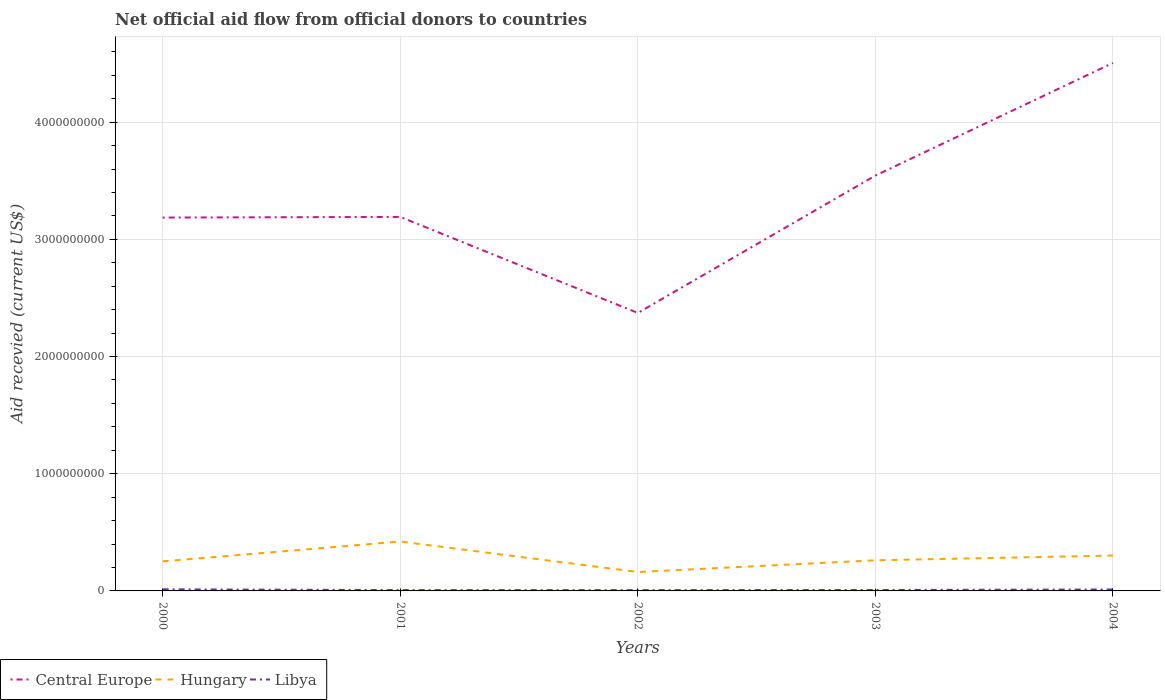Across all years, what is the maximum total aid received in Hungary?
Keep it short and to the point. 1.62e+08. In which year was the total aid received in Central Europe maximum?
Your response must be concise. 2002. What is the total total aid received in Central Europe in the graph?
Provide a succinct answer. 8.19e+08. What is the difference between the highest and the second highest total aid received in Central Europe?
Give a very brief answer. 2.13e+09. Is the total aid received in Hungary strictly greater than the total aid received in Libya over the years?
Ensure brevity in your answer.  No. What is the difference between two consecutive major ticks on the Y-axis?
Keep it short and to the point. 1.00e+09. Are the values on the major ticks of Y-axis written in scientific E-notation?
Keep it short and to the point. No. Does the graph contain grids?
Offer a very short reply. Yes. Where does the legend appear in the graph?
Your answer should be very brief. Bottom left. How many legend labels are there?
Your answer should be very brief. 3. What is the title of the graph?
Offer a very short reply. Net official aid flow from official donors to countries. What is the label or title of the Y-axis?
Keep it short and to the point. Aid recevied (current US$). What is the Aid recevied (current US$) in Central Europe in 2000?
Keep it short and to the point. 3.19e+09. What is the Aid recevied (current US$) in Hungary in 2000?
Ensure brevity in your answer.  2.52e+08. What is the Aid recevied (current US$) in Libya in 2000?
Provide a succinct answer. 1.38e+07. What is the Aid recevied (current US$) in Central Europe in 2001?
Ensure brevity in your answer.  3.19e+09. What is the Aid recevied (current US$) of Hungary in 2001?
Keep it short and to the point. 4.22e+08. What is the Aid recevied (current US$) in Libya in 2001?
Your answer should be very brief. 7.14e+06. What is the Aid recevied (current US$) of Central Europe in 2002?
Give a very brief answer. 2.37e+09. What is the Aid recevied (current US$) in Hungary in 2002?
Your answer should be very brief. 1.62e+08. What is the Aid recevied (current US$) of Libya in 2002?
Your answer should be very brief. 6.88e+06. What is the Aid recevied (current US$) of Central Europe in 2003?
Your response must be concise. 3.54e+09. What is the Aid recevied (current US$) of Hungary in 2003?
Keep it short and to the point. 2.61e+08. What is the Aid recevied (current US$) in Libya in 2003?
Make the answer very short. 7.95e+06. What is the Aid recevied (current US$) in Central Europe in 2004?
Give a very brief answer. 4.51e+09. What is the Aid recevied (current US$) of Hungary in 2004?
Your response must be concise. 3.02e+08. What is the Aid recevied (current US$) in Libya in 2004?
Offer a terse response. 1.24e+07. Across all years, what is the maximum Aid recevied (current US$) in Central Europe?
Ensure brevity in your answer.  4.51e+09. Across all years, what is the maximum Aid recevied (current US$) of Hungary?
Your answer should be compact. 4.22e+08. Across all years, what is the maximum Aid recevied (current US$) in Libya?
Offer a very short reply. 1.38e+07. Across all years, what is the minimum Aid recevied (current US$) in Central Europe?
Ensure brevity in your answer.  2.37e+09. Across all years, what is the minimum Aid recevied (current US$) of Hungary?
Offer a very short reply. 1.62e+08. Across all years, what is the minimum Aid recevied (current US$) in Libya?
Offer a very short reply. 6.88e+06. What is the total Aid recevied (current US$) in Central Europe in the graph?
Make the answer very short. 1.68e+1. What is the total Aid recevied (current US$) of Hungary in the graph?
Your response must be concise. 1.40e+09. What is the total Aid recevied (current US$) in Libya in the graph?
Your answer should be very brief. 4.82e+07. What is the difference between the Aid recevied (current US$) in Central Europe in 2000 and that in 2001?
Your answer should be compact. -5.47e+06. What is the difference between the Aid recevied (current US$) of Hungary in 2000 and that in 2001?
Offer a very short reply. -1.70e+08. What is the difference between the Aid recevied (current US$) of Libya in 2000 and that in 2001?
Offer a very short reply. 6.61e+06. What is the difference between the Aid recevied (current US$) in Central Europe in 2000 and that in 2002?
Provide a short and direct response. 8.14e+08. What is the difference between the Aid recevied (current US$) of Hungary in 2000 and that in 2002?
Offer a very short reply. 9.06e+07. What is the difference between the Aid recevied (current US$) of Libya in 2000 and that in 2002?
Offer a terse response. 6.87e+06. What is the difference between the Aid recevied (current US$) in Central Europe in 2000 and that in 2003?
Provide a short and direct response. -3.59e+08. What is the difference between the Aid recevied (current US$) of Hungary in 2000 and that in 2003?
Offer a very short reply. -9.28e+06. What is the difference between the Aid recevied (current US$) of Libya in 2000 and that in 2003?
Provide a short and direct response. 5.80e+06. What is the difference between the Aid recevied (current US$) of Central Europe in 2000 and that in 2004?
Your answer should be very brief. -1.32e+09. What is the difference between the Aid recevied (current US$) in Hungary in 2000 and that in 2004?
Make the answer very short. -4.98e+07. What is the difference between the Aid recevied (current US$) in Libya in 2000 and that in 2004?
Make the answer very short. 1.32e+06. What is the difference between the Aid recevied (current US$) in Central Europe in 2001 and that in 2002?
Provide a succinct answer. 8.19e+08. What is the difference between the Aid recevied (current US$) in Hungary in 2001 and that in 2002?
Your response must be concise. 2.60e+08. What is the difference between the Aid recevied (current US$) in Central Europe in 2001 and that in 2003?
Your answer should be compact. -3.53e+08. What is the difference between the Aid recevied (current US$) in Hungary in 2001 and that in 2003?
Ensure brevity in your answer.  1.60e+08. What is the difference between the Aid recevied (current US$) of Libya in 2001 and that in 2003?
Offer a terse response. -8.10e+05. What is the difference between the Aid recevied (current US$) in Central Europe in 2001 and that in 2004?
Offer a very short reply. -1.31e+09. What is the difference between the Aid recevied (current US$) in Hungary in 2001 and that in 2004?
Make the answer very short. 1.20e+08. What is the difference between the Aid recevied (current US$) of Libya in 2001 and that in 2004?
Make the answer very short. -5.29e+06. What is the difference between the Aid recevied (current US$) of Central Europe in 2002 and that in 2003?
Keep it short and to the point. -1.17e+09. What is the difference between the Aid recevied (current US$) in Hungary in 2002 and that in 2003?
Your answer should be very brief. -9.99e+07. What is the difference between the Aid recevied (current US$) of Libya in 2002 and that in 2003?
Offer a terse response. -1.07e+06. What is the difference between the Aid recevied (current US$) in Central Europe in 2002 and that in 2004?
Provide a short and direct response. -2.13e+09. What is the difference between the Aid recevied (current US$) of Hungary in 2002 and that in 2004?
Give a very brief answer. -1.40e+08. What is the difference between the Aid recevied (current US$) in Libya in 2002 and that in 2004?
Provide a short and direct response. -5.55e+06. What is the difference between the Aid recevied (current US$) in Central Europe in 2003 and that in 2004?
Ensure brevity in your answer.  -9.61e+08. What is the difference between the Aid recevied (current US$) in Hungary in 2003 and that in 2004?
Provide a succinct answer. -4.06e+07. What is the difference between the Aid recevied (current US$) of Libya in 2003 and that in 2004?
Provide a succinct answer. -4.48e+06. What is the difference between the Aid recevied (current US$) in Central Europe in 2000 and the Aid recevied (current US$) in Hungary in 2001?
Give a very brief answer. 2.76e+09. What is the difference between the Aid recevied (current US$) in Central Europe in 2000 and the Aid recevied (current US$) in Libya in 2001?
Ensure brevity in your answer.  3.18e+09. What is the difference between the Aid recevied (current US$) in Hungary in 2000 and the Aid recevied (current US$) in Libya in 2001?
Ensure brevity in your answer.  2.45e+08. What is the difference between the Aid recevied (current US$) in Central Europe in 2000 and the Aid recevied (current US$) in Hungary in 2002?
Keep it short and to the point. 3.02e+09. What is the difference between the Aid recevied (current US$) in Central Europe in 2000 and the Aid recevied (current US$) in Libya in 2002?
Make the answer very short. 3.18e+09. What is the difference between the Aid recevied (current US$) of Hungary in 2000 and the Aid recevied (current US$) of Libya in 2002?
Provide a succinct answer. 2.45e+08. What is the difference between the Aid recevied (current US$) in Central Europe in 2000 and the Aid recevied (current US$) in Hungary in 2003?
Provide a short and direct response. 2.92e+09. What is the difference between the Aid recevied (current US$) of Central Europe in 2000 and the Aid recevied (current US$) of Libya in 2003?
Ensure brevity in your answer.  3.18e+09. What is the difference between the Aid recevied (current US$) of Hungary in 2000 and the Aid recevied (current US$) of Libya in 2003?
Your answer should be very brief. 2.44e+08. What is the difference between the Aid recevied (current US$) of Central Europe in 2000 and the Aid recevied (current US$) of Hungary in 2004?
Provide a succinct answer. 2.88e+09. What is the difference between the Aid recevied (current US$) in Central Europe in 2000 and the Aid recevied (current US$) in Libya in 2004?
Provide a succinct answer. 3.17e+09. What is the difference between the Aid recevied (current US$) in Hungary in 2000 and the Aid recevied (current US$) in Libya in 2004?
Offer a very short reply. 2.40e+08. What is the difference between the Aid recevied (current US$) of Central Europe in 2001 and the Aid recevied (current US$) of Hungary in 2002?
Your answer should be compact. 3.03e+09. What is the difference between the Aid recevied (current US$) in Central Europe in 2001 and the Aid recevied (current US$) in Libya in 2002?
Offer a very short reply. 3.18e+09. What is the difference between the Aid recevied (current US$) in Hungary in 2001 and the Aid recevied (current US$) in Libya in 2002?
Your answer should be very brief. 4.15e+08. What is the difference between the Aid recevied (current US$) of Central Europe in 2001 and the Aid recevied (current US$) of Hungary in 2003?
Your answer should be very brief. 2.93e+09. What is the difference between the Aid recevied (current US$) of Central Europe in 2001 and the Aid recevied (current US$) of Libya in 2003?
Give a very brief answer. 3.18e+09. What is the difference between the Aid recevied (current US$) of Hungary in 2001 and the Aid recevied (current US$) of Libya in 2003?
Provide a short and direct response. 4.14e+08. What is the difference between the Aid recevied (current US$) in Central Europe in 2001 and the Aid recevied (current US$) in Hungary in 2004?
Provide a succinct answer. 2.89e+09. What is the difference between the Aid recevied (current US$) in Central Europe in 2001 and the Aid recevied (current US$) in Libya in 2004?
Your answer should be very brief. 3.18e+09. What is the difference between the Aid recevied (current US$) in Hungary in 2001 and the Aid recevied (current US$) in Libya in 2004?
Provide a succinct answer. 4.09e+08. What is the difference between the Aid recevied (current US$) of Central Europe in 2002 and the Aid recevied (current US$) of Hungary in 2003?
Your answer should be very brief. 2.11e+09. What is the difference between the Aid recevied (current US$) in Central Europe in 2002 and the Aid recevied (current US$) in Libya in 2003?
Keep it short and to the point. 2.36e+09. What is the difference between the Aid recevied (current US$) in Hungary in 2002 and the Aid recevied (current US$) in Libya in 2003?
Your answer should be compact. 1.54e+08. What is the difference between the Aid recevied (current US$) in Central Europe in 2002 and the Aid recevied (current US$) in Hungary in 2004?
Ensure brevity in your answer.  2.07e+09. What is the difference between the Aid recevied (current US$) in Central Europe in 2002 and the Aid recevied (current US$) in Libya in 2004?
Ensure brevity in your answer.  2.36e+09. What is the difference between the Aid recevied (current US$) of Hungary in 2002 and the Aid recevied (current US$) of Libya in 2004?
Your answer should be compact. 1.49e+08. What is the difference between the Aid recevied (current US$) in Central Europe in 2003 and the Aid recevied (current US$) in Hungary in 2004?
Offer a very short reply. 3.24e+09. What is the difference between the Aid recevied (current US$) in Central Europe in 2003 and the Aid recevied (current US$) in Libya in 2004?
Your response must be concise. 3.53e+09. What is the difference between the Aid recevied (current US$) of Hungary in 2003 and the Aid recevied (current US$) of Libya in 2004?
Make the answer very short. 2.49e+08. What is the average Aid recevied (current US$) in Central Europe per year?
Ensure brevity in your answer.  3.36e+09. What is the average Aid recevied (current US$) in Hungary per year?
Your answer should be compact. 2.80e+08. What is the average Aid recevied (current US$) in Libya per year?
Your answer should be very brief. 9.63e+06. In the year 2000, what is the difference between the Aid recevied (current US$) of Central Europe and Aid recevied (current US$) of Hungary?
Ensure brevity in your answer.  2.93e+09. In the year 2000, what is the difference between the Aid recevied (current US$) of Central Europe and Aid recevied (current US$) of Libya?
Ensure brevity in your answer.  3.17e+09. In the year 2000, what is the difference between the Aid recevied (current US$) of Hungary and Aid recevied (current US$) of Libya?
Provide a succinct answer. 2.38e+08. In the year 2001, what is the difference between the Aid recevied (current US$) in Central Europe and Aid recevied (current US$) in Hungary?
Provide a short and direct response. 2.77e+09. In the year 2001, what is the difference between the Aid recevied (current US$) in Central Europe and Aid recevied (current US$) in Libya?
Offer a terse response. 3.18e+09. In the year 2001, what is the difference between the Aid recevied (current US$) of Hungary and Aid recevied (current US$) of Libya?
Keep it short and to the point. 4.15e+08. In the year 2002, what is the difference between the Aid recevied (current US$) of Central Europe and Aid recevied (current US$) of Hungary?
Offer a very short reply. 2.21e+09. In the year 2002, what is the difference between the Aid recevied (current US$) in Central Europe and Aid recevied (current US$) in Libya?
Provide a succinct answer. 2.37e+09. In the year 2002, what is the difference between the Aid recevied (current US$) of Hungary and Aid recevied (current US$) of Libya?
Ensure brevity in your answer.  1.55e+08. In the year 2003, what is the difference between the Aid recevied (current US$) of Central Europe and Aid recevied (current US$) of Hungary?
Provide a succinct answer. 3.28e+09. In the year 2003, what is the difference between the Aid recevied (current US$) of Central Europe and Aid recevied (current US$) of Libya?
Make the answer very short. 3.54e+09. In the year 2003, what is the difference between the Aid recevied (current US$) of Hungary and Aid recevied (current US$) of Libya?
Provide a succinct answer. 2.54e+08. In the year 2004, what is the difference between the Aid recevied (current US$) in Central Europe and Aid recevied (current US$) in Hungary?
Provide a succinct answer. 4.20e+09. In the year 2004, what is the difference between the Aid recevied (current US$) in Central Europe and Aid recevied (current US$) in Libya?
Provide a short and direct response. 4.49e+09. In the year 2004, what is the difference between the Aid recevied (current US$) of Hungary and Aid recevied (current US$) of Libya?
Your answer should be compact. 2.90e+08. What is the ratio of the Aid recevied (current US$) in Central Europe in 2000 to that in 2001?
Offer a terse response. 1. What is the ratio of the Aid recevied (current US$) in Hungary in 2000 to that in 2001?
Give a very brief answer. 0.6. What is the ratio of the Aid recevied (current US$) in Libya in 2000 to that in 2001?
Provide a short and direct response. 1.93. What is the ratio of the Aid recevied (current US$) of Central Europe in 2000 to that in 2002?
Make the answer very short. 1.34. What is the ratio of the Aid recevied (current US$) of Hungary in 2000 to that in 2002?
Your answer should be compact. 1.56. What is the ratio of the Aid recevied (current US$) of Libya in 2000 to that in 2002?
Offer a very short reply. 2. What is the ratio of the Aid recevied (current US$) of Central Europe in 2000 to that in 2003?
Offer a very short reply. 0.9. What is the ratio of the Aid recevied (current US$) in Hungary in 2000 to that in 2003?
Give a very brief answer. 0.96. What is the ratio of the Aid recevied (current US$) of Libya in 2000 to that in 2003?
Keep it short and to the point. 1.73. What is the ratio of the Aid recevied (current US$) in Central Europe in 2000 to that in 2004?
Offer a very short reply. 0.71. What is the ratio of the Aid recevied (current US$) in Hungary in 2000 to that in 2004?
Provide a succinct answer. 0.83. What is the ratio of the Aid recevied (current US$) in Libya in 2000 to that in 2004?
Offer a very short reply. 1.11. What is the ratio of the Aid recevied (current US$) of Central Europe in 2001 to that in 2002?
Provide a short and direct response. 1.35. What is the ratio of the Aid recevied (current US$) of Hungary in 2001 to that in 2002?
Your answer should be very brief. 2.61. What is the ratio of the Aid recevied (current US$) in Libya in 2001 to that in 2002?
Provide a succinct answer. 1.04. What is the ratio of the Aid recevied (current US$) in Central Europe in 2001 to that in 2003?
Keep it short and to the point. 0.9. What is the ratio of the Aid recevied (current US$) of Hungary in 2001 to that in 2003?
Make the answer very short. 1.61. What is the ratio of the Aid recevied (current US$) of Libya in 2001 to that in 2003?
Your answer should be very brief. 0.9. What is the ratio of the Aid recevied (current US$) in Central Europe in 2001 to that in 2004?
Offer a very short reply. 0.71. What is the ratio of the Aid recevied (current US$) of Hungary in 2001 to that in 2004?
Make the answer very short. 1.4. What is the ratio of the Aid recevied (current US$) in Libya in 2001 to that in 2004?
Offer a very short reply. 0.57. What is the ratio of the Aid recevied (current US$) in Central Europe in 2002 to that in 2003?
Keep it short and to the point. 0.67. What is the ratio of the Aid recevied (current US$) of Hungary in 2002 to that in 2003?
Ensure brevity in your answer.  0.62. What is the ratio of the Aid recevied (current US$) in Libya in 2002 to that in 2003?
Keep it short and to the point. 0.87. What is the ratio of the Aid recevied (current US$) of Central Europe in 2002 to that in 2004?
Make the answer very short. 0.53. What is the ratio of the Aid recevied (current US$) in Hungary in 2002 to that in 2004?
Give a very brief answer. 0.53. What is the ratio of the Aid recevied (current US$) of Libya in 2002 to that in 2004?
Give a very brief answer. 0.55. What is the ratio of the Aid recevied (current US$) of Central Europe in 2003 to that in 2004?
Your answer should be very brief. 0.79. What is the ratio of the Aid recevied (current US$) in Hungary in 2003 to that in 2004?
Offer a terse response. 0.87. What is the ratio of the Aid recevied (current US$) in Libya in 2003 to that in 2004?
Ensure brevity in your answer.  0.64. What is the difference between the highest and the second highest Aid recevied (current US$) in Central Europe?
Your response must be concise. 9.61e+08. What is the difference between the highest and the second highest Aid recevied (current US$) of Hungary?
Your answer should be compact. 1.20e+08. What is the difference between the highest and the second highest Aid recevied (current US$) of Libya?
Keep it short and to the point. 1.32e+06. What is the difference between the highest and the lowest Aid recevied (current US$) of Central Europe?
Offer a terse response. 2.13e+09. What is the difference between the highest and the lowest Aid recevied (current US$) in Hungary?
Your answer should be very brief. 2.60e+08. What is the difference between the highest and the lowest Aid recevied (current US$) of Libya?
Offer a very short reply. 6.87e+06. 